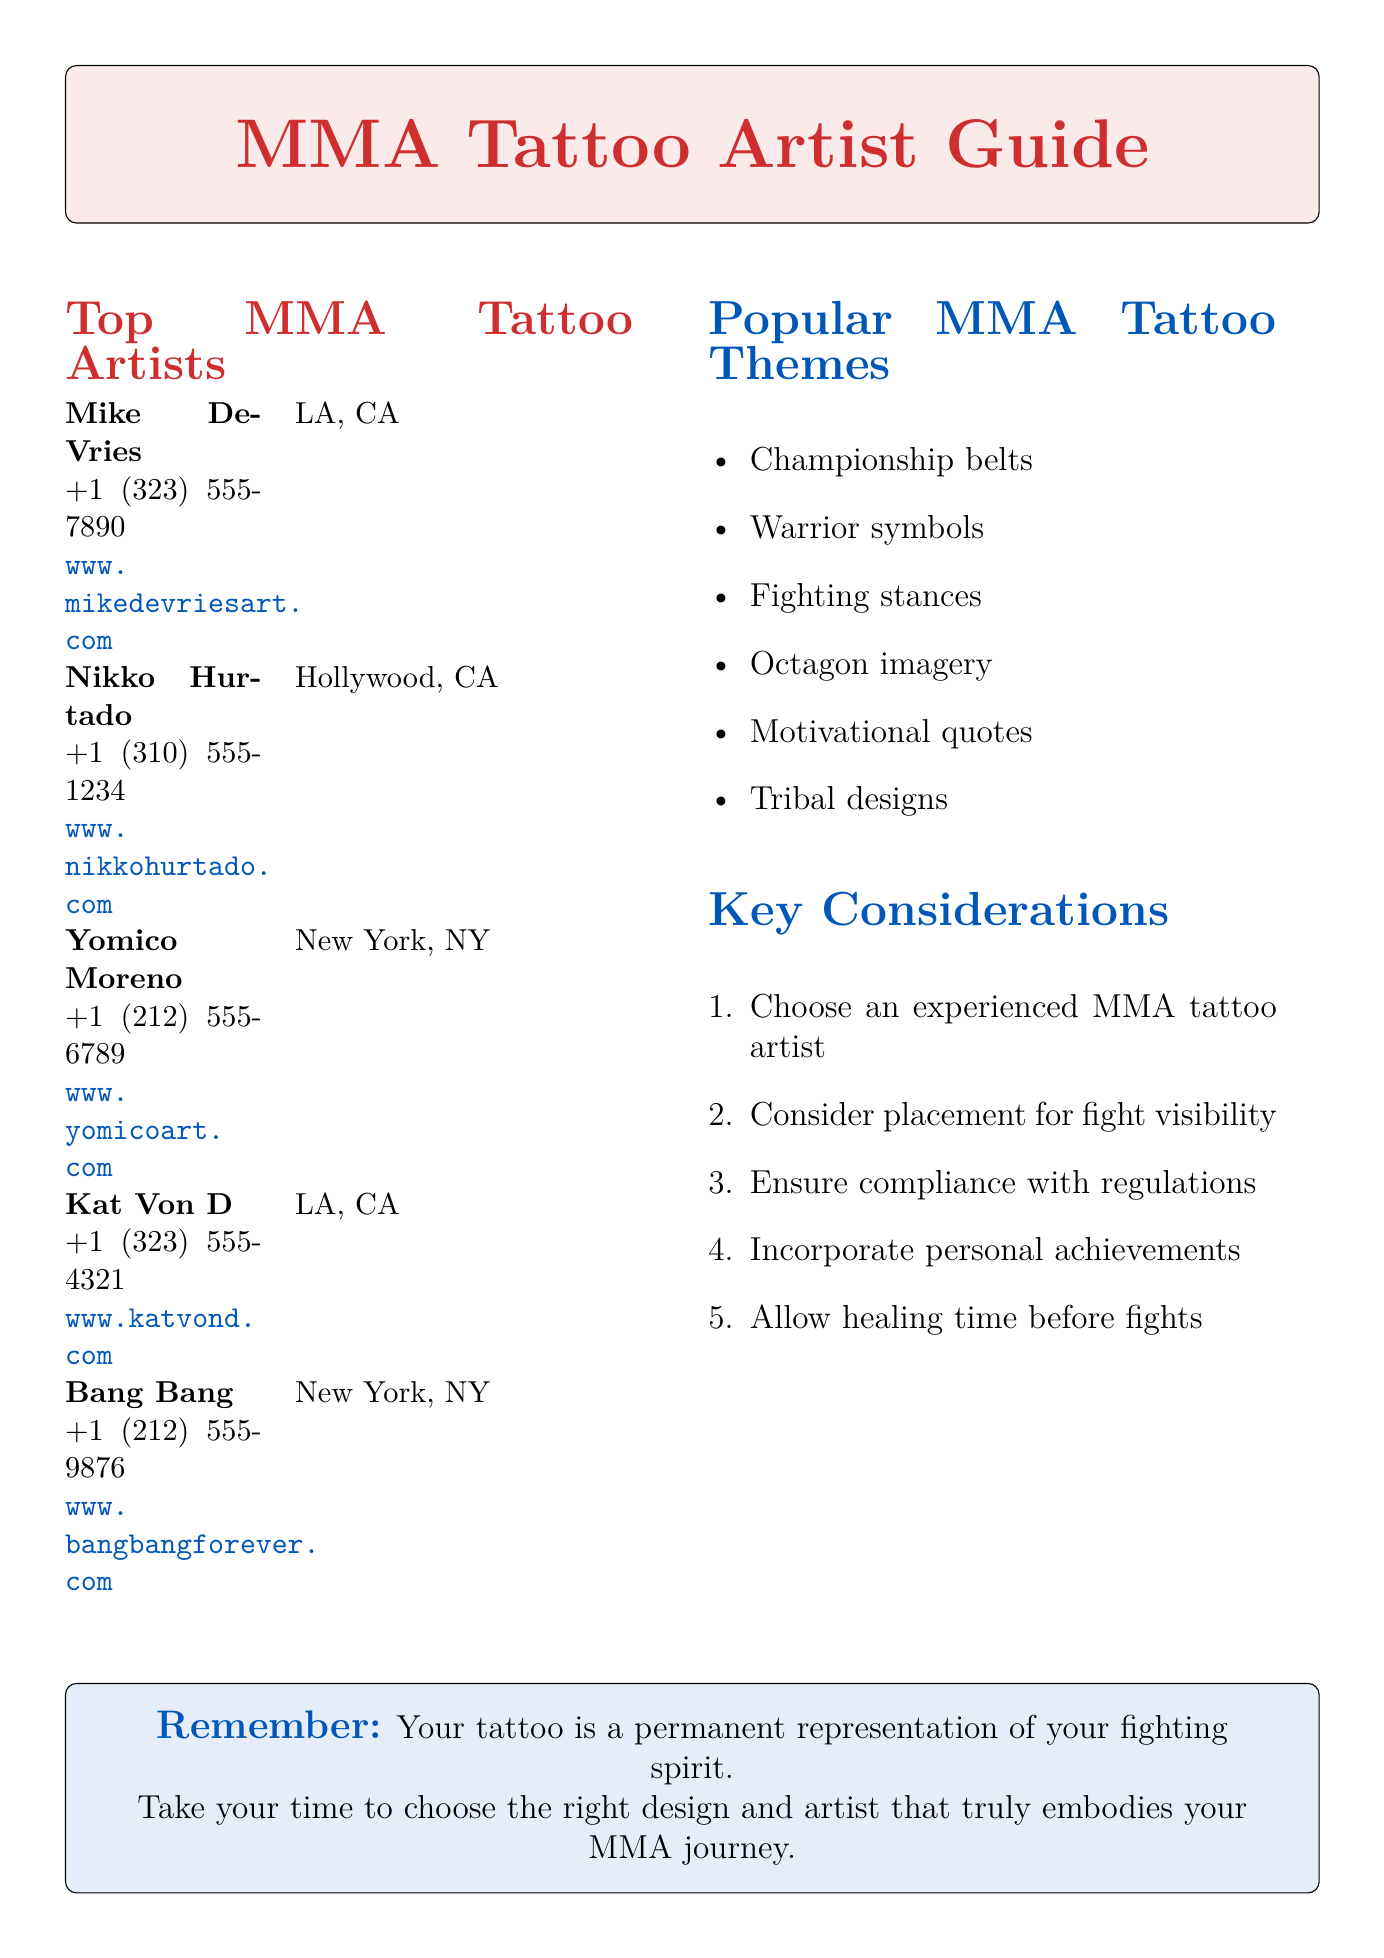What is the name of the tattoo artist who specializes in realistic MMA portraits? The document lists Mike DeVries as the tattoo artist specializing in realistic MMA portraits.
Answer: Mike DeVries What notable client did Nikko Hurtado tattoo? The document specifies Ronda Rousey as a notable client of Nikko Hurtado.
Answer: Ronda Rousey Which tattoo artist is located in New York, NY? The document mentions both Yomico Moreno and Bang Bang are located in New York, NY.
Answer: Yomico Moreno, Bang Bang What is one popular MMA tattoo theme mentioned in the document? The document includes a list of popular MMA tattoo themes, and one example is championship belts.
Answer: Championship belts How many artists are listed in the document? The document enumerates five tattoo artists in total.
Answer: Five What is a key consideration for getting a tattoo before fights? The document advises to allow ample time for healing before upcoming fights.
Answer: Allow healing time What type of tattoos does Kat Von D specialize in? The document specifies that Kat Von D specializes in black and grey MMA-themed tattoos.
Answer: Black and grey MMA-themed tattoos What is a common element in tattoo designs mentioned in the document? The document lists various themes like warrior symbols as a common element in tattoo designs.
Answer: Warrior symbols 